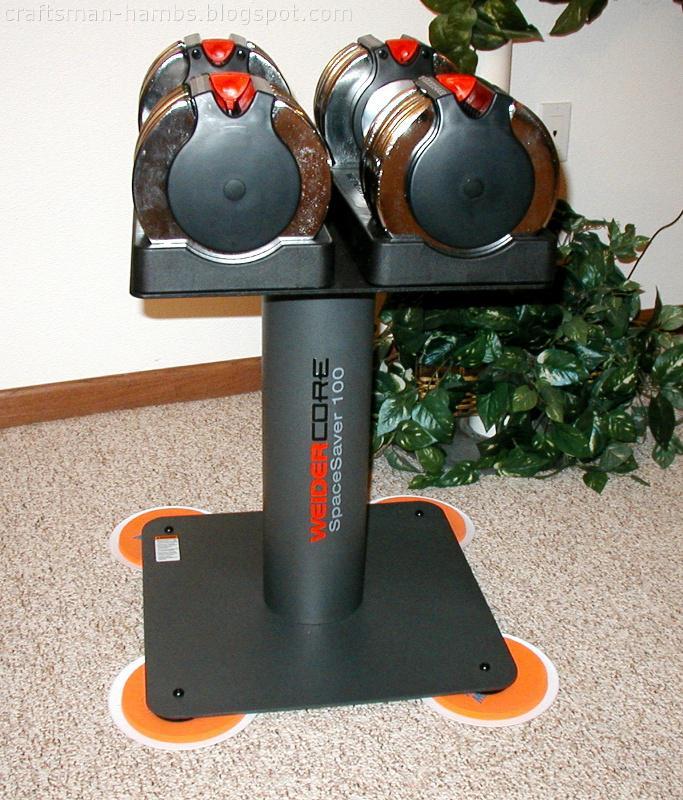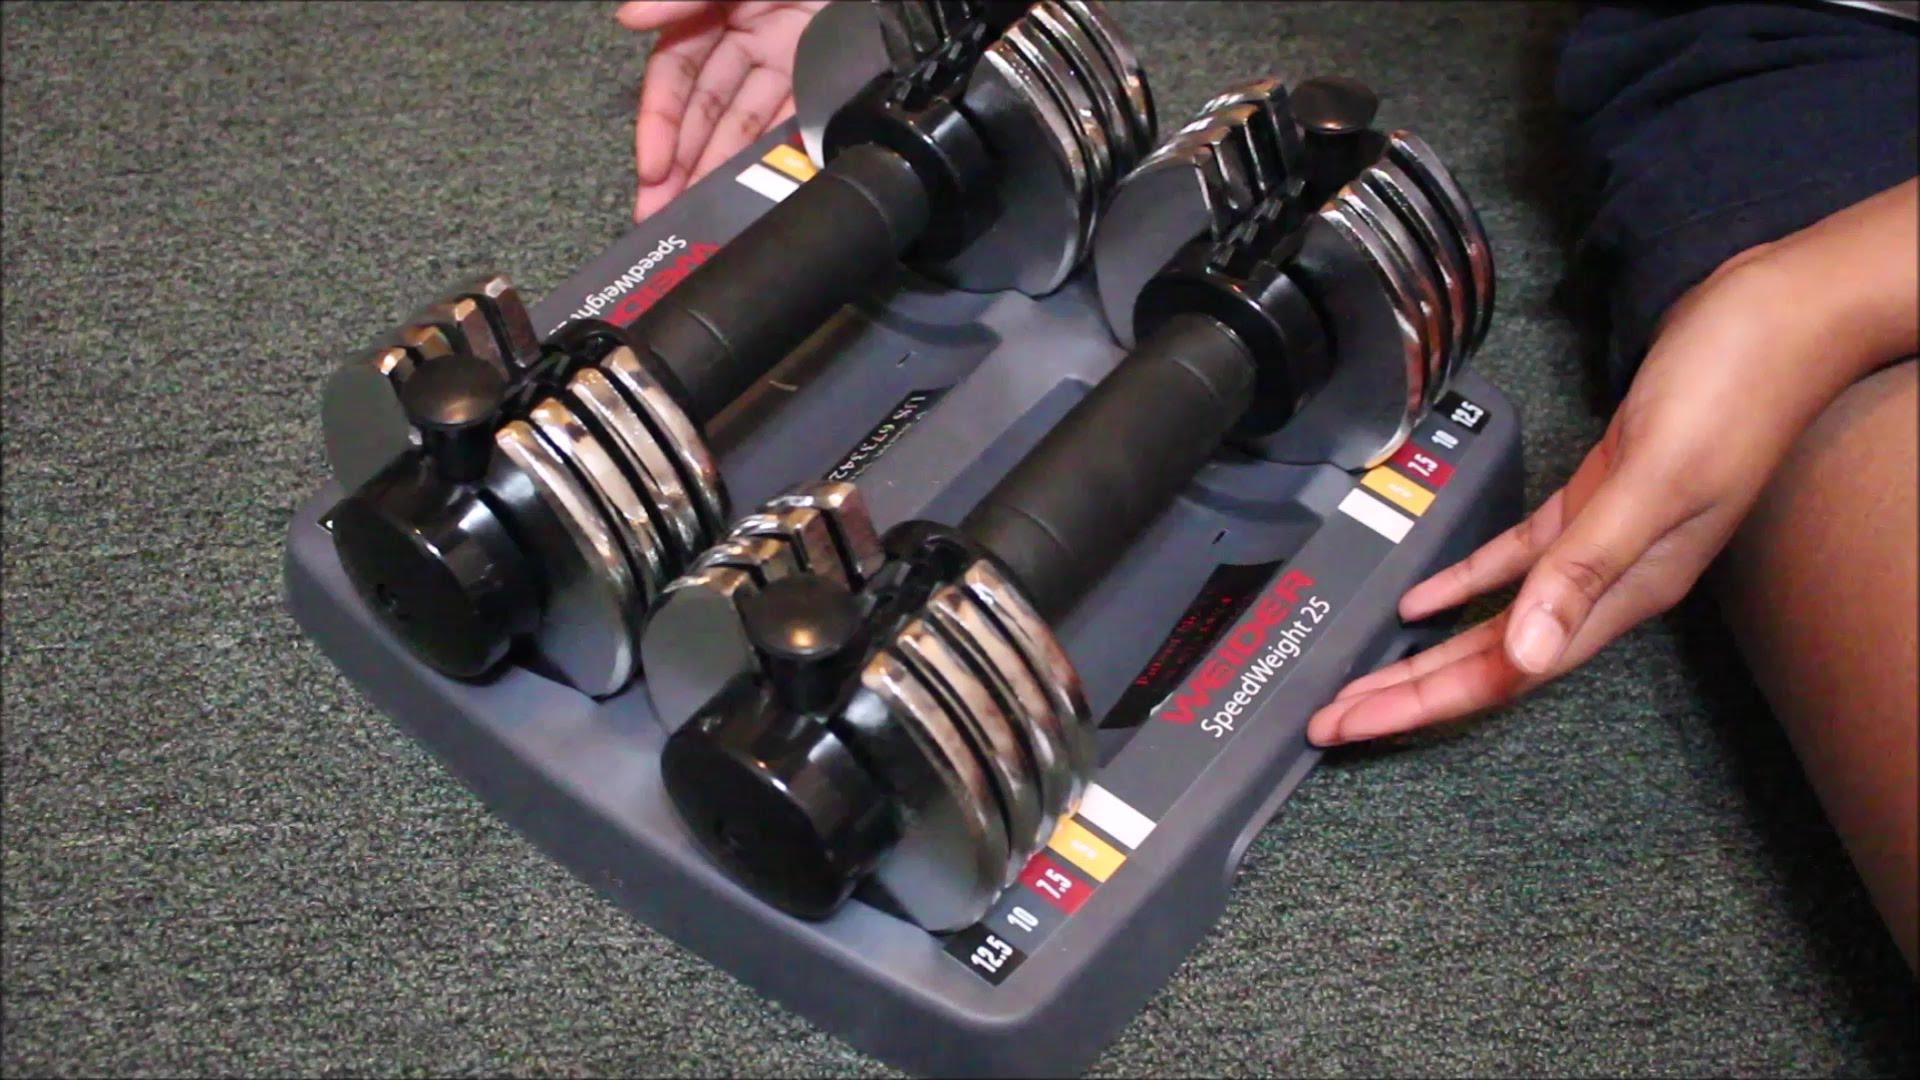The first image is the image on the left, the second image is the image on the right. Examine the images to the left and right. Is the description "The left and right image contains the same number of weights sitting on a tower." accurate? Answer yes or no. No. The first image is the image on the left, the second image is the image on the right. Evaluate the accuracy of this statement regarding the images: "Each image includes one pair of dumbbell bars with weights, and at least one image shows the dumbbells on a stand with a square base.". Is it true? Answer yes or no. Yes. 